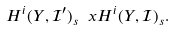Convert formula to latex. <formula><loc_0><loc_0><loc_500><loc_500>H ^ { i } ( Y , \mathcal { I } ^ { \prime } ) _ { s } \ x H ^ { i } ( Y , \mathcal { I } ) _ { s } .</formula> 